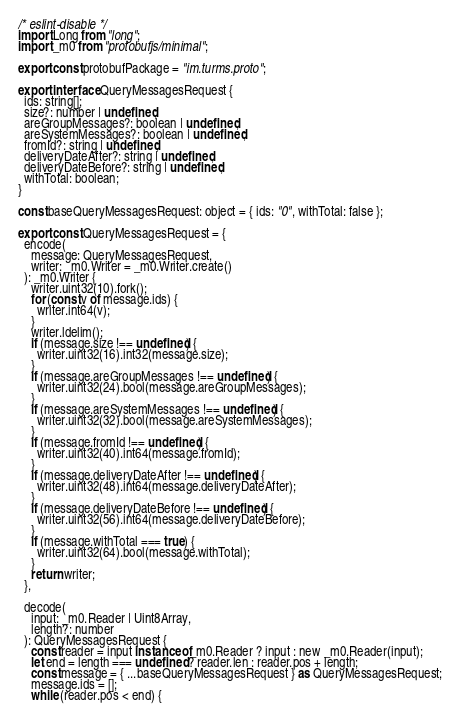Convert code to text. <code><loc_0><loc_0><loc_500><loc_500><_TypeScript_>/* eslint-disable */
import Long from "long";
import _m0 from "protobufjs/minimal";

export const protobufPackage = "im.turms.proto";

export interface QueryMessagesRequest {
  ids: string[];
  size?: number | undefined;
  areGroupMessages?: boolean | undefined;
  areSystemMessages?: boolean | undefined;
  fromId?: string | undefined;
  deliveryDateAfter?: string | undefined;
  deliveryDateBefore?: string | undefined;
  withTotal: boolean;
}

const baseQueryMessagesRequest: object = { ids: "0", withTotal: false };

export const QueryMessagesRequest = {
  encode(
    message: QueryMessagesRequest,
    writer: _m0.Writer = _m0.Writer.create()
  ): _m0.Writer {
    writer.uint32(10).fork();
    for (const v of message.ids) {
      writer.int64(v);
    }
    writer.ldelim();
    if (message.size !== undefined) {
      writer.uint32(16).int32(message.size);
    }
    if (message.areGroupMessages !== undefined) {
      writer.uint32(24).bool(message.areGroupMessages);
    }
    if (message.areSystemMessages !== undefined) {
      writer.uint32(32).bool(message.areSystemMessages);
    }
    if (message.fromId !== undefined) {
      writer.uint32(40).int64(message.fromId);
    }
    if (message.deliveryDateAfter !== undefined) {
      writer.uint32(48).int64(message.deliveryDateAfter);
    }
    if (message.deliveryDateBefore !== undefined) {
      writer.uint32(56).int64(message.deliveryDateBefore);
    }
    if (message.withTotal === true) {
      writer.uint32(64).bool(message.withTotal);
    }
    return writer;
  },

  decode(
    input: _m0.Reader | Uint8Array,
    length?: number
  ): QueryMessagesRequest {
    const reader = input instanceof _m0.Reader ? input : new _m0.Reader(input);
    let end = length === undefined ? reader.len : reader.pos + length;
    const message = { ...baseQueryMessagesRequest } as QueryMessagesRequest;
    message.ids = [];
    while (reader.pos < end) {</code> 